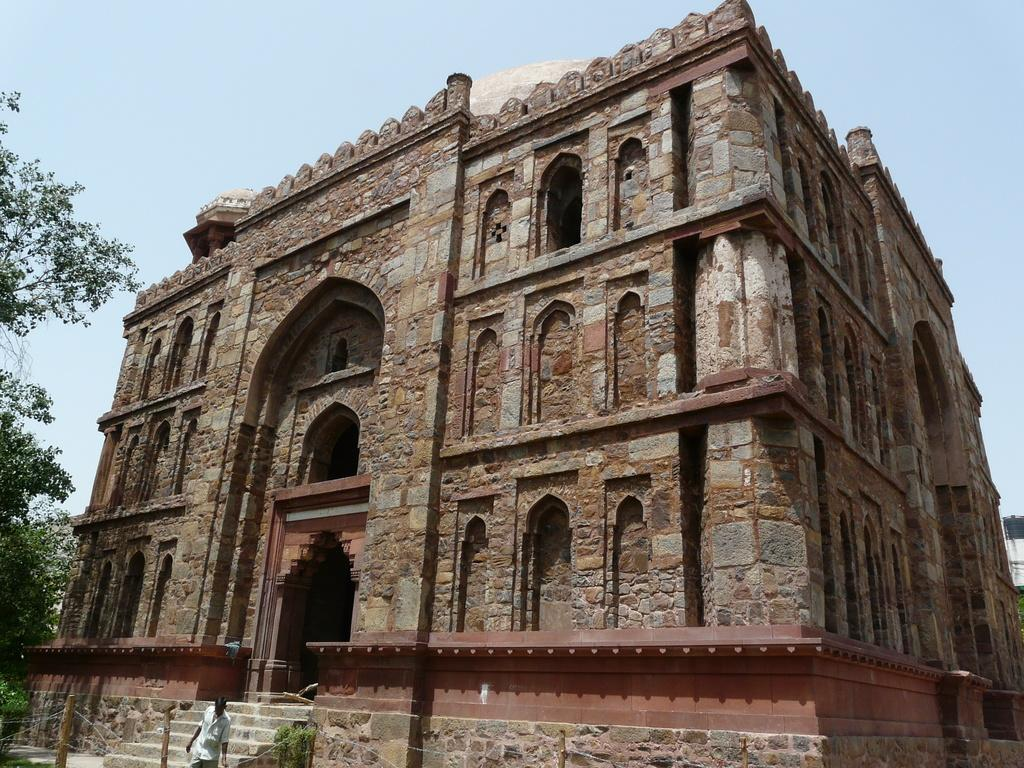What structure is present in the image? There is a building in the image. Who or what is in front of the building? There is a man in front of the building. What type of vegetation can be seen on the left side of the image? Trees are visible on the left side of the image. What is visible in the background of the image? The sky is visible in the background of the image. How many visitors are standing on the man's leg in the image? There are no visitors present in the image, and the man's leg is not visible. 